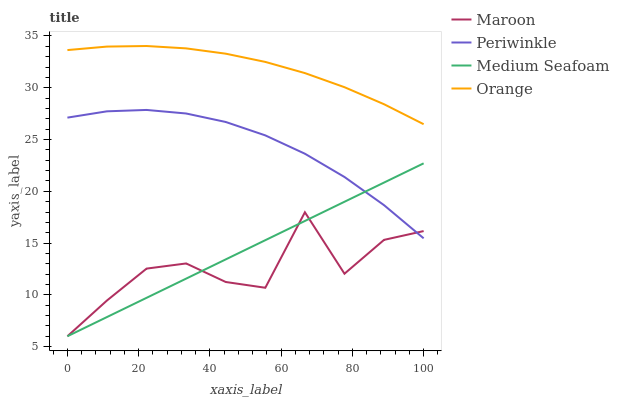Does Maroon have the minimum area under the curve?
Answer yes or no. Yes. Does Orange have the maximum area under the curve?
Answer yes or no. Yes. Does Periwinkle have the minimum area under the curve?
Answer yes or no. No. Does Periwinkle have the maximum area under the curve?
Answer yes or no. No. Is Medium Seafoam the smoothest?
Answer yes or no. Yes. Is Maroon the roughest?
Answer yes or no. Yes. Is Periwinkle the smoothest?
Answer yes or no. No. Is Periwinkle the roughest?
Answer yes or no. No. Does Periwinkle have the lowest value?
Answer yes or no. No. Does Orange have the highest value?
Answer yes or no. Yes. Does Periwinkle have the highest value?
Answer yes or no. No. Is Periwinkle less than Orange?
Answer yes or no. Yes. Is Orange greater than Medium Seafoam?
Answer yes or no. Yes. Does Periwinkle intersect Orange?
Answer yes or no. No. 